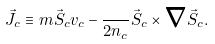Convert formula to latex. <formula><loc_0><loc_0><loc_500><loc_500>\vec { J } _ { c } \equiv m \vec { S } _ { c } { v } _ { c } - \frac { } { 2 n _ { c } } \vec { S } _ { c } \times { \boldsymbol \nabla } \vec { S } _ { c } .</formula> 